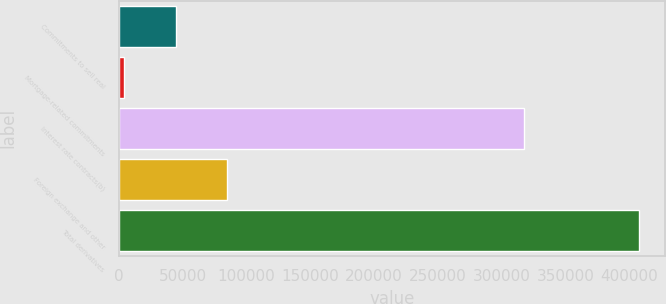Convert chart. <chart><loc_0><loc_0><loc_500><loc_500><bar_chart><fcel>Commitments to sell real<fcel>Mortgage-related commitments<fcel>Interest rate contracts(b)<fcel>Foreign exchange and other<fcel>Total derivatives<nl><fcel>44762.7<fcel>4428<fcel>317651<fcel>85097.4<fcel>407775<nl></chart> 